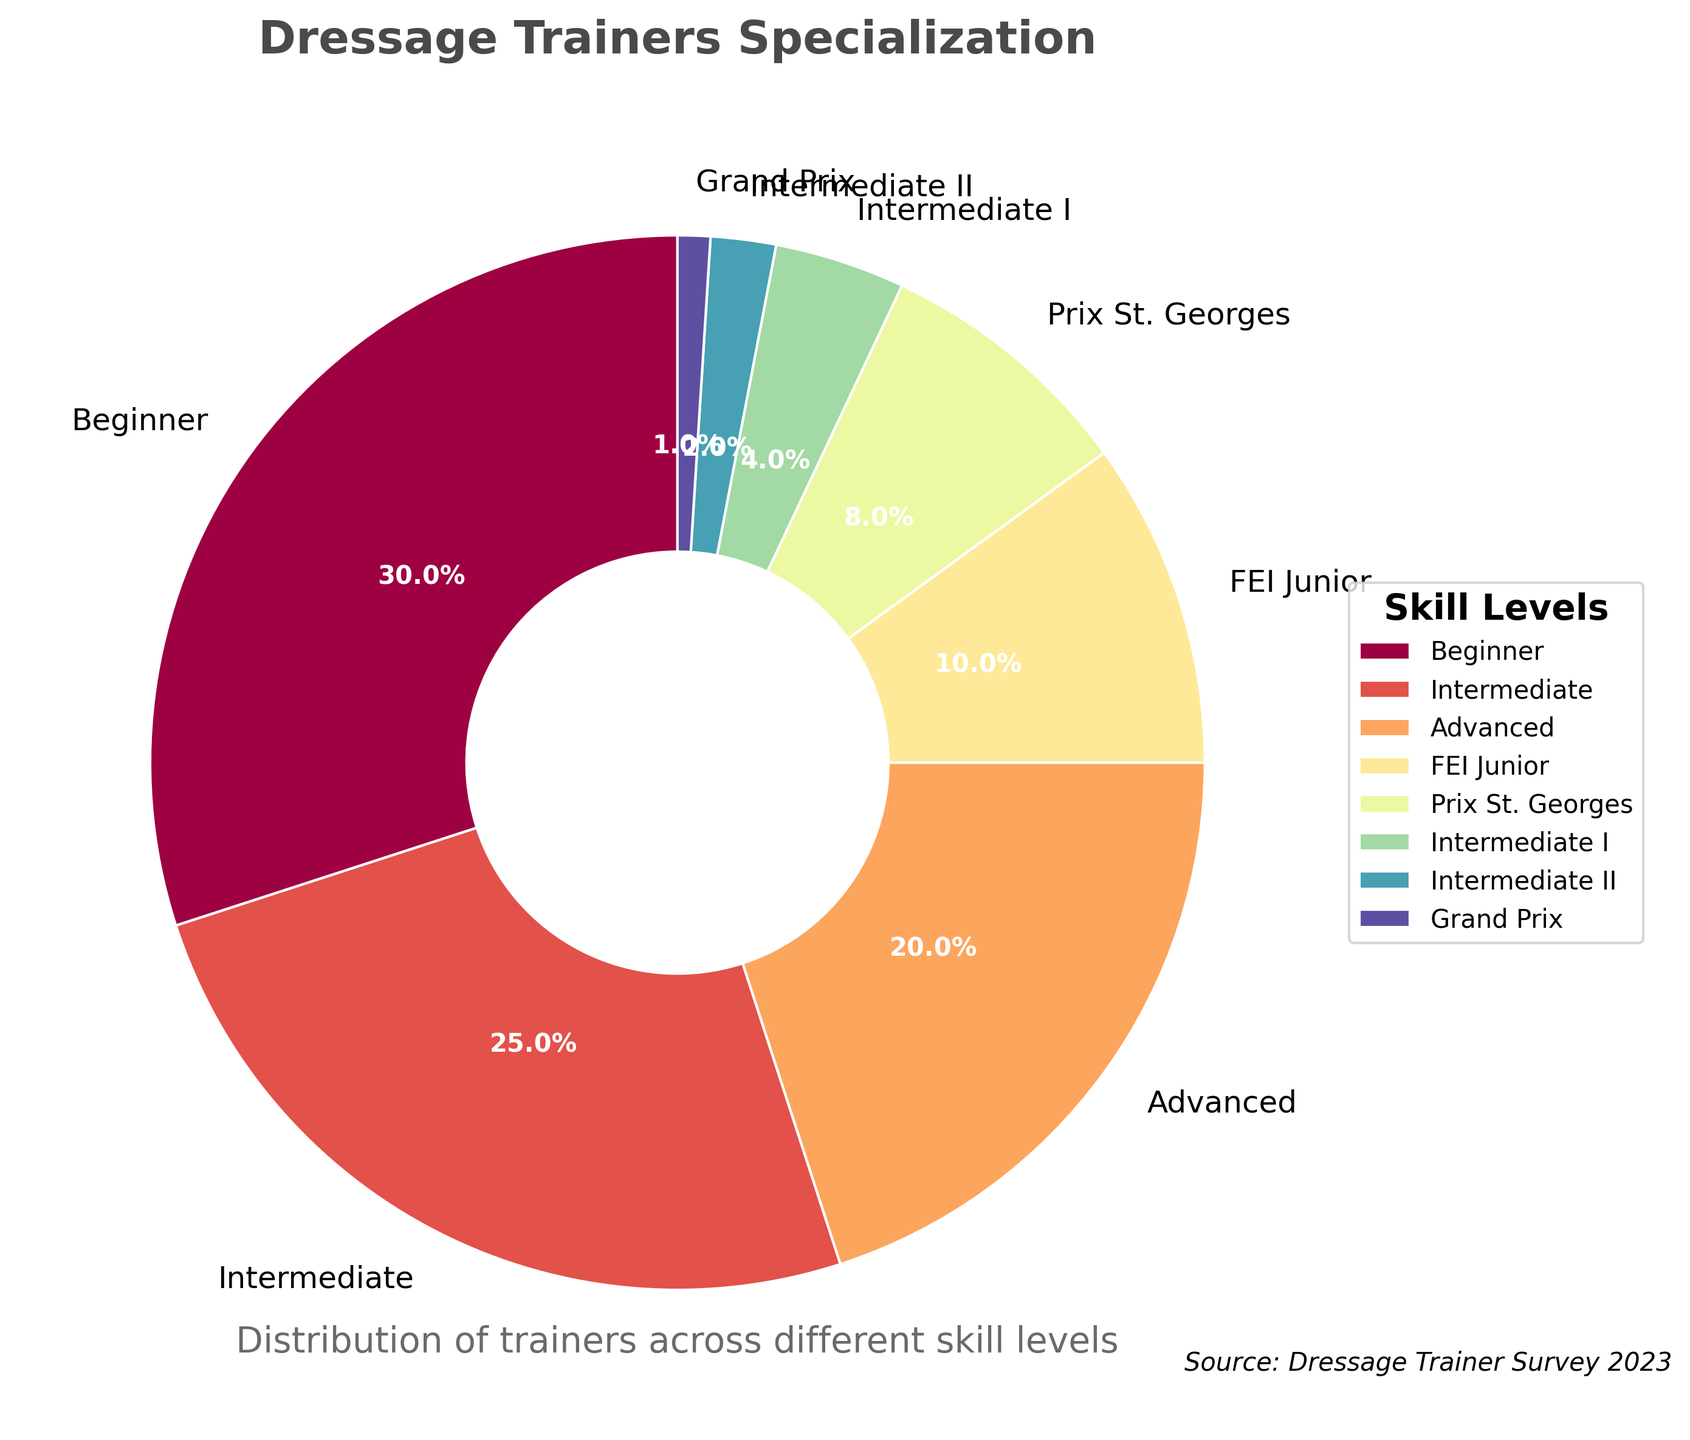What is the title of the chart? The title is located at the top center of the chart and provides an overview of the figure's content. It is "Dressage Trainers Specialization."
Answer: Dressage Trainers Specialization What percentage of trainers specialize in the Beginner skill level? Locate the "Beginner" section of the pie chart, and note the percentage value displayed within or beside that section. The percentage is 30%.
Answer: 30% Which skill level has the smallest percentage of dressage trainers? Identify the smallest wedge in the pie chart and read the label next to it. The smallest percentage corresponds to "Grand Prix," which has 1%.
Answer: Grand Prix What is the combined percentage of trainers specializing in Intermediate I and Intermediate II? Find the percentages labeled for "Intermediate I" and "Intermediate II." Add these values: 4% for Intermediate I + 2% for Intermediate II = 6%.
Answer: 6% How does the percentage of trainers at the FEI Junior level compare to those at the Intermediate level? Locate the percentages for "FEI Junior" (10%) and "Intermediate" (25%). Compare them to see which is greater. The Intermediate level has a higher percentage.
Answer: The Intermediate level is higher What is the total percentage of trainers specializing in Advanced, Prix St. Georges, Intermediate I, and Intermediate II skill levels? Sum the percentages of the specified skill levels: Advanced (20%), Prix St. Georges (8%), Intermediate I (4%), and Intermediate II (2%). 20% + 8% + 4% + 2% = 34%.
Answer: 34% Which skill level has exactly half the percentage of trainers compared to the Beginner category? The Beginner category has 30%. Half of this is 15%. The skill level with a percentage closest to 15% is "Intermediate" with 25%, so there is no exact match, but "Intermediate" is the closest.
Answer: None exactly; Intermediate is closest What is the difference in percentage between Prix St. Georges and Intermediate I skill levels? Find the percentages for "Prix St. Georges" (8%) and "Intermediate I" (4%). Subtract the smaller percentage from the larger one: 8% - 4% = 4%.
Answer: 4% What do the colors of each wedge represent in the pie chart? Each wedge in the pie chart has a distinct color corresponding to a specific skill level of dressage trainers. The colors are distributed according to the designated colormap to differentiate the categories visually. Each color represents a specific skill level listed in the legend.
Answer: Skill levels distribution 